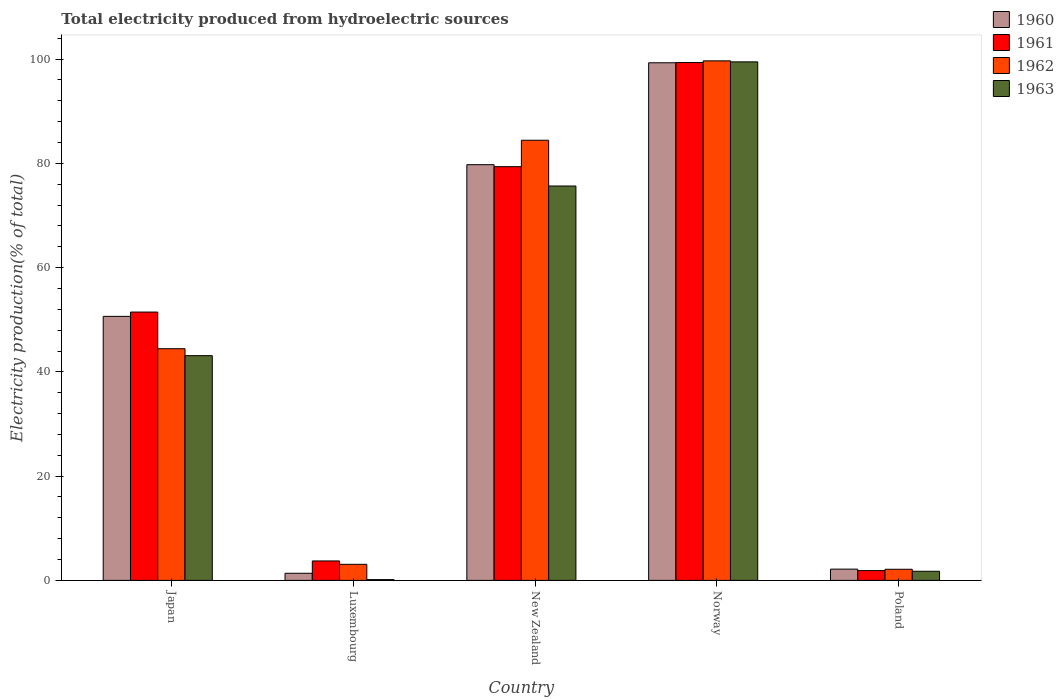Are the number of bars per tick equal to the number of legend labels?
Keep it short and to the point. Yes. How many bars are there on the 5th tick from the right?
Provide a succinct answer. 4. What is the total electricity produced in 1961 in New Zealand?
Your response must be concise. 79.37. Across all countries, what is the maximum total electricity produced in 1961?
Provide a short and direct response. 99.34. Across all countries, what is the minimum total electricity produced in 1963?
Make the answer very short. 0.15. In which country was the total electricity produced in 1961 maximum?
Your answer should be compact. Norway. What is the total total electricity produced in 1960 in the graph?
Give a very brief answer. 233.22. What is the difference between the total electricity produced in 1963 in Japan and that in New Zealand?
Provide a succinct answer. -32.54. What is the difference between the total electricity produced in 1963 in New Zealand and the total electricity produced in 1960 in Luxembourg?
Provide a short and direct response. 74.29. What is the average total electricity produced in 1961 per country?
Your answer should be compact. 47.16. What is the difference between the total electricity produced of/in 1963 and total electricity produced of/in 1962 in Luxembourg?
Your answer should be very brief. -2.93. In how many countries, is the total electricity produced in 1962 greater than 16 %?
Your answer should be very brief. 3. What is the ratio of the total electricity produced in 1963 in Norway to that in Poland?
Your response must be concise. 56.8. What is the difference between the highest and the second highest total electricity produced in 1961?
Provide a short and direct response. -47.87. What is the difference between the highest and the lowest total electricity produced in 1962?
Your answer should be compact. 97.54. In how many countries, is the total electricity produced in 1960 greater than the average total electricity produced in 1960 taken over all countries?
Keep it short and to the point. 3. Is the sum of the total electricity produced in 1960 in Japan and Norway greater than the maximum total electricity produced in 1963 across all countries?
Offer a very short reply. Yes. What does the 4th bar from the left in Luxembourg represents?
Offer a very short reply. 1963. Are all the bars in the graph horizontal?
Your answer should be very brief. No. How many countries are there in the graph?
Your response must be concise. 5. Does the graph contain any zero values?
Ensure brevity in your answer.  No. Does the graph contain grids?
Your answer should be compact. No. What is the title of the graph?
Offer a very short reply. Total electricity produced from hydroelectric sources. Does "1969" appear as one of the legend labels in the graph?
Your answer should be compact. No. What is the Electricity production(% of total) in 1960 in Japan?
Provide a short and direct response. 50.65. What is the Electricity production(% of total) of 1961 in Japan?
Ensure brevity in your answer.  51.48. What is the Electricity production(% of total) of 1962 in Japan?
Ensure brevity in your answer.  44.44. What is the Electricity production(% of total) of 1963 in Japan?
Offer a terse response. 43.11. What is the Electricity production(% of total) of 1960 in Luxembourg?
Your answer should be compact. 1.37. What is the Electricity production(% of total) in 1961 in Luxembourg?
Provide a short and direct response. 3.73. What is the Electricity production(% of total) in 1962 in Luxembourg?
Provide a short and direct response. 3.08. What is the Electricity production(% of total) of 1963 in Luxembourg?
Provide a succinct answer. 0.15. What is the Electricity production(% of total) of 1960 in New Zealand?
Your response must be concise. 79.75. What is the Electricity production(% of total) of 1961 in New Zealand?
Provide a succinct answer. 79.37. What is the Electricity production(% of total) in 1962 in New Zealand?
Provide a short and direct response. 84.44. What is the Electricity production(% of total) of 1963 in New Zealand?
Keep it short and to the point. 75.66. What is the Electricity production(% of total) in 1960 in Norway?
Your response must be concise. 99.3. What is the Electricity production(% of total) of 1961 in Norway?
Your response must be concise. 99.34. What is the Electricity production(% of total) of 1962 in Norway?
Offer a very short reply. 99.67. What is the Electricity production(% of total) in 1963 in Norway?
Your answer should be very brief. 99.47. What is the Electricity production(% of total) in 1960 in Poland?
Give a very brief answer. 2.16. What is the Electricity production(% of total) in 1961 in Poland?
Your answer should be compact. 1.87. What is the Electricity production(% of total) in 1962 in Poland?
Ensure brevity in your answer.  2.13. What is the Electricity production(% of total) in 1963 in Poland?
Your answer should be very brief. 1.75. Across all countries, what is the maximum Electricity production(% of total) in 1960?
Your answer should be compact. 99.3. Across all countries, what is the maximum Electricity production(% of total) of 1961?
Make the answer very short. 99.34. Across all countries, what is the maximum Electricity production(% of total) of 1962?
Provide a short and direct response. 99.67. Across all countries, what is the maximum Electricity production(% of total) of 1963?
Offer a very short reply. 99.47. Across all countries, what is the minimum Electricity production(% of total) of 1960?
Provide a succinct answer. 1.37. Across all countries, what is the minimum Electricity production(% of total) of 1961?
Make the answer very short. 1.87. Across all countries, what is the minimum Electricity production(% of total) in 1962?
Provide a succinct answer. 2.13. Across all countries, what is the minimum Electricity production(% of total) of 1963?
Offer a very short reply. 0.15. What is the total Electricity production(% of total) in 1960 in the graph?
Your answer should be very brief. 233.22. What is the total Electricity production(% of total) in 1961 in the graph?
Provide a succinct answer. 235.79. What is the total Electricity production(% of total) of 1962 in the graph?
Provide a succinct answer. 233.77. What is the total Electricity production(% of total) in 1963 in the graph?
Provide a short and direct response. 220.15. What is the difference between the Electricity production(% of total) of 1960 in Japan and that in Luxembourg?
Offer a very short reply. 49.28. What is the difference between the Electricity production(% of total) of 1961 in Japan and that in Luxembourg?
Provide a succinct answer. 47.75. What is the difference between the Electricity production(% of total) of 1962 in Japan and that in Luxembourg?
Give a very brief answer. 41.36. What is the difference between the Electricity production(% of total) in 1963 in Japan and that in Luxembourg?
Keep it short and to the point. 42.97. What is the difference between the Electricity production(% of total) of 1960 in Japan and that in New Zealand?
Provide a short and direct response. -29.1. What is the difference between the Electricity production(% of total) in 1961 in Japan and that in New Zealand?
Offer a terse response. -27.9. What is the difference between the Electricity production(% of total) in 1962 in Japan and that in New Zealand?
Your response must be concise. -39.99. What is the difference between the Electricity production(% of total) in 1963 in Japan and that in New Zealand?
Your response must be concise. -32.54. What is the difference between the Electricity production(% of total) in 1960 in Japan and that in Norway?
Provide a short and direct response. -48.65. What is the difference between the Electricity production(% of total) in 1961 in Japan and that in Norway?
Provide a short and direct response. -47.87. What is the difference between the Electricity production(% of total) of 1962 in Japan and that in Norway?
Your answer should be very brief. -55.23. What is the difference between the Electricity production(% of total) in 1963 in Japan and that in Norway?
Ensure brevity in your answer.  -56.36. What is the difference between the Electricity production(% of total) in 1960 in Japan and that in Poland?
Your answer should be compact. 48.49. What is the difference between the Electricity production(% of total) in 1961 in Japan and that in Poland?
Offer a terse response. 49.6. What is the difference between the Electricity production(% of total) of 1962 in Japan and that in Poland?
Offer a terse response. 42.31. What is the difference between the Electricity production(% of total) of 1963 in Japan and that in Poland?
Your answer should be compact. 41.36. What is the difference between the Electricity production(% of total) of 1960 in Luxembourg and that in New Zealand?
Provide a succinct answer. -78.38. What is the difference between the Electricity production(% of total) of 1961 in Luxembourg and that in New Zealand?
Keep it short and to the point. -75.64. What is the difference between the Electricity production(% of total) in 1962 in Luxembourg and that in New Zealand?
Offer a terse response. -81.36. What is the difference between the Electricity production(% of total) of 1963 in Luxembourg and that in New Zealand?
Ensure brevity in your answer.  -75.51. What is the difference between the Electricity production(% of total) in 1960 in Luxembourg and that in Norway?
Provide a short and direct response. -97.93. What is the difference between the Electricity production(% of total) of 1961 in Luxembourg and that in Norway?
Keep it short and to the point. -95.61. What is the difference between the Electricity production(% of total) in 1962 in Luxembourg and that in Norway?
Ensure brevity in your answer.  -96.59. What is the difference between the Electricity production(% of total) of 1963 in Luxembourg and that in Norway?
Make the answer very short. -99.33. What is the difference between the Electricity production(% of total) in 1960 in Luxembourg and that in Poland?
Offer a very short reply. -0.79. What is the difference between the Electricity production(% of total) in 1961 in Luxembourg and that in Poland?
Give a very brief answer. 1.86. What is the difference between the Electricity production(% of total) in 1962 in Luxembourg and that in Poland?
Ensure brevity in your answer.  0.95. What is the difference between the Electricity production(% of total) of 1963 in Luxembourg and that in Poland?
Give a very brief answer. -1.6. What is the difference between the Electricity production(% of total) of 1960 in New Zealand and that in Norway?
Provide a short and direct response. -19.55. What is the difference between the Electricity production(% of total) of 1961 in New Zealand and that in Norway?
Give a very brief answer. -19.97. What is the difference between the Electricity production(% of total) of 1962 in New Zealand and that in Norway?
Provide a succinct answer. -15.23. What is the difference between the Electricity production(% of total) of 1963 in New Zealand and that in Norway?
Offer a very short reply. -23.82. What is the difference between the Electricity production(% of total) in 1960 in New Zealand and that in Poland?
Provide a short and direct response. 77.59. What is the difference between the Electricity production(% of total) in 1961 in New Zealand and that in Poland?
Provide a succinct answer. 77.5. What is the difference between the Electricity production(% of total) in 1962 in New Zealand and that in Poland?
Your response must be concise. 82.31. What is the difference between the Electricity production(% of total) in 1963 in New Zealand and that in Poland?
Offer a very short reply. 73.91. What is the difference between the Electricity production(% of total) of 1960 in Norway and that in Poland?
Ensure brevity in your answer.  97.14. What is the difference between the Electricity production(% of total) in 1961 in Norway and that in Poland?
Ensure brevity in your answer.  97.47. What is the difference between the Electricity production(% of total) in 1962 in Norway and that in Poland?
Give a very brief answer. 97.54. What is the difference between the Electricity production(% of total) of 1963 in Norway and that in Poland?
Offer a very short reply. 97.72. What is the difference between the Electricity production(% of total) in 1960 in Japan and the Electricity production(% of total) in 1961 in Luxembourg?
Ensure brevity in your answer.  46.92. What is the difference between the Electricity production(% of total) of 1960 in Japan and the Electricity production(% of total) of 1962 in Luxembourg?
Give a very brief answer. 47.57. What is the difference between the Electricity production(% of total) in 1960 in Japan and the Electricity production(% of total) in 1963 in Luxembourg?
Your answer should be compact. 50.5. What is the difference between the Electricity production(% of total) in 1961 in Japan and the Electricity production(% of total) in 1962 in Luxembourg?
Keep it short and to the point. 48.39. What is the difference between the Electricity production(% of total) of 1961 in Japan and the Electricity production(% of total) of 1963 in Luxembourg?
Your answer should be compact. 51.33. What is the difference between the Electricity production(% of total) in 1962 in Japan and the Electricity production(% of total) in 1963 in Luxembourg?
Provide a succinct answer. 44.3. What is the difference between the Electricity production(% of total) of 1960 in Japan and the Electricity production(% of total) of 1961 in New Zealand?
Keep it short and to the point. -28.72. What is the difference between the Electricity production(% of total) in 1960 in Japan and the Electricity production(% of total) in 1962 in New Zealand?
Give a very brief answer. -33.79. What is the difference between the Electricity production(% of total) in 1960 in Japan and the Electricity production(% of total) in 1963 in New Zealand?
Ensure brevity in your answer.  -25.01. What is the difference between the Electricity production(% of total) in 1961 in Japan and the Electricity production(% of total) in 1962 in New Zealand?
Ensure brevity in your answer.  -32.96. What is the difference between the Electricity production(% of total) of 1961 in Japan and the Electricity production(% of total) of 1963 in New Zealand?
Provide a succinct answer. -24.18. What is the difference between the Electricity production(% of total) in 1962 in Japan and the Electricity production(% of total) in 1963 in New Zealand?
Your answer should be compact. -31.21. What is the difference between the Electricity production(% of total) in 1960 in Japan and the Electricity production(% of total) in 1961 in Norway?
Give a very brief answer. -48.69. What is the difference between the Electricity production(% of total) of 1960 in Japan and the Electricity production(% of total) of 1962 in Norway?
Your response must be concise. -49.02. What is the difference between the Electricity production(% of total) of 1960 in Japan and the Electricity production(% of total) of 1963 in Norway?
Your response must be concise. -48.83. What is the difference between the Electricity production(% of total) of 1961 in Japan and the Electricity production(% of total) of 1962 in Norway?
Your response must be concise. -48.19. What is the difference between the Electricity production(% of total) of 1961 in Japan and the Electricity production(% of total) of 1963 in Norway?
Your response must be concise. -48. What is the difference between the Electricity production(% of total) in 1962 in Japan and the Electricity production(% of total) in 1963 in Norway?
Provide a short and direct response. -55.03. What is the difference between the Electricity production(% of total) of 1960 in Japan and the Electricity production(% of total) of 1961 in Poland?
Your response must be concise. 48.78. What is the difference between the Electricity production(% of total) in 1960 in Japan and the Electricity production(% of total) in 1962 in Poland?
Your answer should be very brief. 48.52. What is the difference between the Electricity production(% of total) in 1960 in Japan and the Electricity production(% of total) in 1963 in Poland?
Your answer should be very brief. 48.9. What is the difference between the Electricity production(% of total) of 1961 in Japan and the Electricity production(% of total) of 1962 in Poland?
Provide a succinct answer. 49.34. What is the difference between the Electricity production(% of total) in 1961 in Japan and the Electricity production(% of total) in 1963 in Poland?
Keep it short and to the point. 49.72. What is the difference between the Electricity production(% of total) in 1962 in Japan and the Electricity production(% of total) in 1963 in Poland?
Offer a terse response. 42.69. What is the difference between the Electricity production(% of total) in 1960 in Luxembourg and the Electricity production(% of total) in 1961 in New Zealand?
Make the answer very short. -78.01. What is the difference between the Electricity production(% of total) of 1960 in Luxembourg and the Electricity production(% of total) of 1962 in New Zealand?
Make the answer very short. -83.07. What is the difference between the Electricity production(% of total) of 1960 in Luxembourg and the Electricity production(% of total) of 1963 in New Zealand?
Provide a succinct answer. -74.29. What is the difference between the Electricity production(% of total) of 1961 in Luxembourg and the Electricity production(% of total) of 1962 in New Zealand?
Your response must be concise. -80.71. What is the difference between the Electricity production(% of total) of 1961 in Luxembourg and the Electricity production(% of total) of 1963 in New Zealand?
Your answer should be compact. -71.93. What is the difference between the Electricity production(% of total) in 1962 in Luxembourg and the Electricity production(% of total) in 1963 in New Zealand?
Offer a very short reply. -72.58. What is the difference between the Electricity production(% of total) in 1960 in Luxembourg and the Electricity production(% of total) in 1961 in Norway?
Give a very brief answer. -97.98. What is the difference between the Electricity production(% of total) in 1960 in Luxembourg and the Electricity production(% of total) in 1962 in Norway?
Give a very brief answer. -98.3. What is the difference between the Electricity production(% of total) in 1960 in Luxembourg and the Electricity production(% of total) in 1963 in Norway?
Your answer should be compact. -98.11. What is the difference between the Electricity production(% of total) of 1961 in Luxembourg and the Electricity production(% of total) of 1962 in Norway?
Your answer should be very brief. -95.94. What is the difference between the Electricity production(% of total) of 1961 in Luxembourg and the Electricity production(% of total) of 1963 in Norway?
Offer a very short reply. -95.74. What is the difference between the Electricity production(% of total) of 1962 in Luxembourg and the Electricity production(% of total) of 1963 in Norway?
Your response must be concise. -96.39. What is the difference between the Electricity production(% of total) in 1960 in Luxembourg and the Electricity production(% of total) in 1961 in Poland?
Provide a short and direct response. -0.51. What is the difference between the Electricity production(% of total) in 1960 in Luxembourg and the Electricity production(% of total) in 1962 in Poland?
Offer a very short reply. -0.77. What is the difference between the Electricity production(% of total) in 1960 in Luxembourg and the Electricity production(% of total) in 1963 in Poland?
Your answer should be very brief. -0.39. What is the difference between the Electricity production(% of total) in 1961 in Luxembourg and the Electricity production(% of total) in 1962 in Poland?
Keep it short and to the point. 1.6. What is the difference between the Electricity production(% of total) in 1961 in Luxembourg and the Electricity production(% of total) in 1963 in Poland?
Make the answer very short. 1.98. What is the difference between the Electricity production(% of total) of 1962 in Luxembourg and the Electricity production(% of total) of 1963 in Poland?
Your answer should be compact. 1.33. What is the difference between the Electricity production(% of total) of 1960 in New Zealand and the Electricity production(% of total) of 1961 in Norway?
Give a very brief answer. -19.59. What is the difference between the Electricity production(% of total) of 1960 in New Zealand and the Electricity production(% of total) of 1962 in Norway?
Ensure brevity in your answer.  -19.92. What is the difference between the Electricity production(% of total) in 1960 in New Zealand and the Electricity production(% of total) in 1963 in Norway?
Your response must be concise. -19.72. What is the difference between the Electricity production(% of total) of 1961 in New Zealand and the Electricity production(% of total) of 1962 in Norway?
Your answer should be very brief. -20.3. What is the difference between the Electricity production(% of total) of 1961 in New Zealand and the Electricity production(% of total) of 1963 in Norway?
Offer a terse response. -20.1. What is the difference between the Electricity production(% of total) of 1962 in New Zealand and the Electricity production(% of total) of 1963 in Norway?
Make the answer very short. -15.04. What is the difference between the Electricity production(% of total) of 1960 in New Zealand and the Electricity production(% of total) of 1961 in Poland?
Give a very brief answer. 77.88. What is the difference between the Electricity production(% of total) of 1960 in New Zealand and the Electricity production(% of total) of 1962 in Poland?
Keep it short and to the point. 77.62. What is the difference between the Electricity production(% of total) in 1960 in New Zealand and the Electricity production(% of total) in 1963 in Poland?
Give a very brief answer. 78. What is the difference between the Electricity production(% of total) in 1961 in New Zealand and the Electricity production(% of total) in 1962 in Poland?
Make the answer very short. 77.24. What is the difference between the Electricity production(% of total) of 1961 in New Zealand and the Electricity production(% of total) of 1963 in Poland?
Your answer should be compact. 77.62. What is the difference between the Electricity production(% of total) in 1962 in New Zealand and the Electricity production(% of total) in 1963 in Poland?
Your answer should be compact. 82.69. What is the difference between the Electricity production(% of total) in 1960 in Norway and the Electricity production(% of total) in 1961 in Poland?
Your answer should be very brief. 97.43. What is the difference between the Electricity production(% of total) of 1960 in Norway and the Electricity production(% of total) of 1962 in Poland?
Provide a succinct answer. 97.17. What is the difference between the Electricity production(% of total) of 1960 in Norway and the Electricity production(% of total) of 1963 in Poland?
Ensure brevity in your answer.  97.55. What is the difference between the Electricity production(% of total) of 1961 in Norway and the Electricity production(% of total) of 1962 in Poland?
Keep it short and to the point. 97.21. What is the difference between the Electricity production(% of total) of 1961 in Norway and the Electricity production(% of total) of 1963 in Poland?
Your answer should be compact. 97.59. What is the difference between the Electricity production(% of total) of 1962 in Norway and the Electricity production(% of total) of 1963 in Poland?
Your answer should be very brief. 97.92. What is the average Electricity production(% of total) in 1960 per country?
Your response must be concise. 46.65. What is the average Electricity production(% of total) of 1961 per country?
Provide a short and direct response. 47.16. What is the average Electricity production(% of total) of 1962 per country?
Make the answer very short. 46.75. What is the average Electricity production(% of total) in 1963 per country?
Your answer should be very brief. 44.03. What is the difference between the Electricity production(% of total) in 1960 and Electricity production(% of total) in 1961 in Japan?
Ensure brevity in your answer.  -0.83. What is the difference between the Electricity production(% of total) in 1960 and Electricity production(% of total) in 1962 in Japan?
Offer a terse response. 6.2. What is the difference between the Electricity production(% of total) of 1960 and Electricity production(% of total) of 1963 in Japan?
Provide a short and direct response. 7.54. What is the difference between the Electricity production(% of total) in 1961 and Electricity production(% of total) in 1962 in Japan?
Make the answer very short. 7.03. What is the difference between the Electricity production(% of total) in 1961 and Electricity production(% of total) in 1963 in Japan?
Your answer should be very brief. 8.36. What is the difference between the Electricity production(% of total) of 1962 and Electricity production(% of total) of 1963 in Japan?
Your answer should be compact. 1.33. What is the difference between the Electricity production(% of total) of 1960 and Electricity production(% of total) of 1961 in Luxembourg?
Your response must be concise. -2.36. What is the difference between the Electricity production(% of total) of 1960 and Electricity production(% of total) of 1962 in Luxembourg?
Offer a very short reply. -1.72. What is the difference between the Electricity production(% of total) in 1960 and Electricity production(% of total) in 1963 in Luxembourg?
Your answer should be very brief. 1.22. What is the difference between the Electricity production(% of total) in 1961 and Electricity production(% of total) in 1962 in Luxembourg?
Your answer should be very brief. 0.65. What is the difference between the Electricity production(% of total) in 1961 and Electricity production(% of total) in 1963 in Luxembourg?
Make the answer very short. 3.58. What is the difference between the Electricity production(% of total) in 1962 and Electricity production(% of total) in 1963 in Luxembourg?
Offer a very short reply. 2.93. What is the difference between the Electricity production(% of total) in 1960 and Electricity production(% of total) in 1961 in New Zealand?
Offer a very short reply. 0.38. What is the difference between the Electricity production(% of total) in 1960 and Electricity production(% of total) in 1962 in New Zealand?
Ensure brevity in your answer.  -4.69. What is the difference between the Electricity production(% of total) of 1960 and Electricity production(% of total) of 1963 in New Zealand?
Offer a terse response. 4.09. What is the difference between the Electricity production(% of total) of 1961 and Electricity production(% of total) of 1962 in New Zealand?
Offer a very short reply. -5.07. What is the difference between the Electricity production(% of total) in 1961 and Electricity production(% of total) in 1963 in New Zealand?
Ensure brevity in your answer.  3.71. What is the difference between the Electricity production(% of total) in 1962 and Electricity production(% of total) in 1963 in New Zealand?
Give a very brief answer. 8.78. What is the difference between the Electricity production(% of total) in 1960 and Electricity production(% of total) in 1961 in Norway?
Offer a terse response. -0.04. What is the difference between the Electricity production(% of total) of 1960 and Electricity production(% of total) of 1962 in Norway?
Offer a very short reply. -0.37. What is the difference between the Electricity production(% of total) in 1960 and Electricity production(% of total) in 1963 in Norway?
Keep it short and to the point. -0.17. What is the difference between the Electricity production(% of total) in 1961 and Electricity production(% of total) in 1962 in Norway?
Provide a short and direct response. -0.33. What is the difference between the Electricity production(% of total) in 1961 and Electricity production(% of total) in 1963 in Norway?
Provide a short and direct response. -0.13. What is the difference between the Electricity production(% of total) in 1962 and Electricity production(% of total) in 1963 in Norway?
Offer a terse response. 0.19. What is the difference between the Electricity production(% of total) of 1960 and Electricity production(% of total) of 1961 in Poland?
Offer a very short reply. 0.28. What is the difference between the Electricity production(% of total) of 1960 and Electricity production(% of total) of 1962 in Poland?
Your answer should be very brief. 0.03. What is the difference between the Electricity production(% of total) of 1960 and Electricity production(% of total) of 1963 in Poland?
Provide a short and direct response. 0.41. What is the difference between the Electricity production(% of total) of 1961 and Electricity production(% of total) of 1962 in Poland?
Provide a short and direct response. -0.26. What is the difference between the Electricity production(% of total) of 1961 and Electricity production(% of total) of 1963 in Poland?
Offer a very short reply. 0.12. What is the difference between the Electricity production(% of total) of 1962 and Electricity production(% of total) of 1963 in Poland?
Offer a very short reply. 0.38. What is the ratio of the Electricity production(% of total) in 1960 in Japan to that in Luxembourg?
Offer a terse response. 37.08. What is the ratio of the Electricity production(% of total) in 1961 in Japan to that in Luxembourg?
Ensure brevity in your answer.  13.8. What is the ratio of the Electricity production(% of total) of 1962 in Japan to that in Luxembourg?
Give a very brief answer. 14.42. What is the ratio of the Electricity production(% of total) of 1963 in Japan to that in Luxembourg?
Make the answer very short. 292.1. What is the ratio of the Electricity production(% of total) in 1960 in Japan to that in New Zealand?
Your response must be concise. 0.64. What is the ratio of the Electricity production(% of total) in 1961 in Japan to that in New Zealand?
Your answer should be very brief. 0.65. What is the ratio of the Electricity production(% of total) in 1962 in Japan to that in New Zealand?
Offer a terse response. 0.53. What is the ratio of the Electricity production(% of total) in 1963 in Japan to that in New Zealand?
Your answer should be very brief. 0.57. What is the ratio of the Electricity production(% of total) of 1960 in Japan to that in Norway?
Your answer should be very brief. 0.51. What is the ratio of the Electricity production(% of total) of 1961 in Japan to that in Norway?
Provide a short and direct response. 0.52. What is the ratio of the Electricity production(% of total) in 1962 in Japan to that in Norway?
Provide a succinct answer. 0.45. What is the ratio of the Electricity production(% of total) in 1963 in Japan to that in Norway?
Offer a very short reply. 0.43. What is the ratio of the Electricity production(% of total) of 1960 in Japan to that in Poland?
Provide a short and direct response. 23.47. What is the ratio of the Electricity production(% of total) of 1961 in Japan to that in Poland?
Provide a short and direct response. 27.48. What is the ratio of the Electricity production(% of total) of 1962 in Japan to that in Poland?
Provide a short and direct response. 20.85. What is the ratio of the Electricity production(% of total) in 1963 in Japan to that in Poland?
Your answer should be very brief. 24.62. What is the ratio of the Electricity production(% of total) in 1960 in Luxembourg to that in New Zealand?
Your answer should be compact. 0.02. What is the ratio of the Electricity production(% of total) of 1961 in Luxembourg to that in New Zealand?
Ensure brevity in your answer.  0.05. What is the ratio of the Electricity production(% of total) of 1962 in Luxembourg to that in New Zealand?
Your answer should be very brief. 0.04. What is the ratio of the Electricity production(% of total) in 1963 in Luxembourg to that in New Zealand?
Ensure brevity in your answer.  0. What is the ratio of the Electricity production(% of total) of 1960 in Luxembourg to that in Norway?
Your response must be concise. 0.01. What is the ratio of the Electricity production(% of total) in 1961 in Luxembourg to that in Norway?
Your answer should be very brief. 0.04. What is the ratio of the Electricity production(% of total) of 1962 in Luxembourg to that in Norway?
Your answer should be compact. 0.03. What is the ratio of the Electricity production(% of total) of 1963 in Luxembourg to that in Norway?
Make the answer very short. 0. What is the ratio of the Electricity production(% of total) in 1960 in Luxembourg to that in Poland?
Offer a very short reply. 0.63. What is the ratio of the Electricity production(% of total) in 1961 in Luxembourg to that in Poland?
Your answer should be compact. 1.99. What is the ratio of the Electricity production(% of total) in 1962 in Luxembourg to that in Poland?
Make the answer very short. 1.45. What is the ratio of the Electricity production(% of total) of 1963 in Luxembourg to that in Poland?
Provide a short and direct response. 0.08. What is the ratio of the Electricity production(% of total) in 1960 in New Zealand to that in Norway?
Your response must be concise. 0.8. What is the ratio of the Electricity production(% of total) of 1961 in New Zealand to that in Norway?
Your answer should be compact. 0.8. What is the ratio of the Electricity production(% of total) in 1962 in New Zealand to that in Norway?
Make the answer very short. 0.85. What is the ratio of the Electricity production(% of total) of 1963 in New Zealand to that in Norway?
Make the answer very short. 0.76. What is the ratio of the Electricity production(% of total) of 1960 in New Zealand to that in Poland?
Your answer should be compact. 36.95. What is the ratio of the Electricity production(% of total) in 1961 in New Zealand to that in Poland?
Make the answer very short. 42.37. What is the ratio of the Electricity production(% of total) of 1962 in New Zealand to that in Poland?
Make the answer very short. 39.6. What is the ratio of the Electricity production(% of total) of 1963 in New Zealand to that in Poland?
Provide a short and direct response. 43.2. What is the ratio of the Electricity production(% of total) of 1960 in Norway to that in Poland?
Offer a very short reply. 46.01. What is the ratio of the Electricity production(% of total) in 1961 in Norway to that in Poland?
Keep it short and to the point. 53.03. What is the ratio of the Electricity production(% of total) of 1962 in Norway to that in Poland?
Provide a short and direct response. 46.75. What is the ratio of the Electricity production(% of total) in 1963 in Norway to that in Poland?
Make the answer very short. 56.8. What is the difference between the highest and the second highest Electricity production(% of total) in 1960?
Keep it short and to the point. 19.55. What is the difference between the highest and the second highest Electricity production(% of total) of 1961?
Provide a succinct answer. 19.97. What is the difference between the highest and the second highest Electricity production(% of total) in 1962?
Give a very brief answer. 15.23. What is the difference between the highest and the second highest Electricity production(% of total) in 1963?
Your response must be concise. 23.82. What is the difference between the highest and the lowest Electricity production(% of total) of 1960?
Offer a terse response. 97.93. What is the difference between the highest and the lowest Electricity production(% of total) of 1961?
Give a very brief answer. 97.47. What is the difference between the highest and the lowest Electricity production(% of total) of 1962?
Provide a succinct answer. 97.54. What is the difference between the highest and the lowest Electricity production(% of total) in 1963?
Offer a terse response. 99.33. 